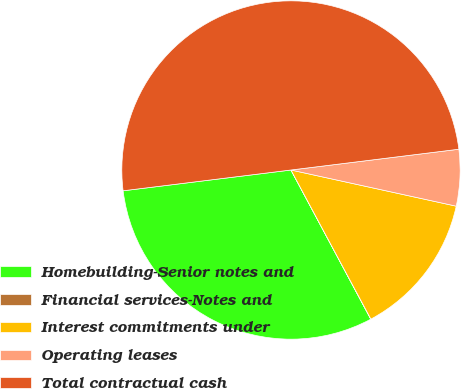<chart> <loc_0><loc_0><loc_500><loc_500><pie_chart><fcel>Homebuilding-Senior notes and<fcel>Financial services-Notes and<fcel>Interest commitments under<fcel>Operating leases<fcel>Total contractual cash<nl><fcel>30.86%<fcel>0.01%<fcel>13.74%<fcel>5.39%<fcel>50.0%<nl></chart> 